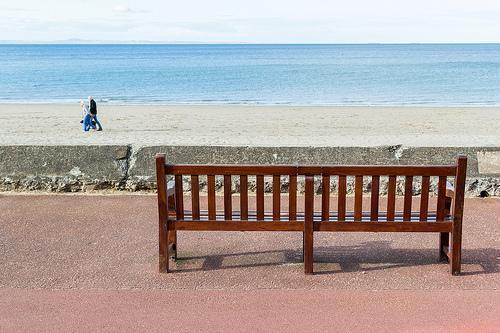How many benches facing the beach?
Give a very brief answer. 1. 